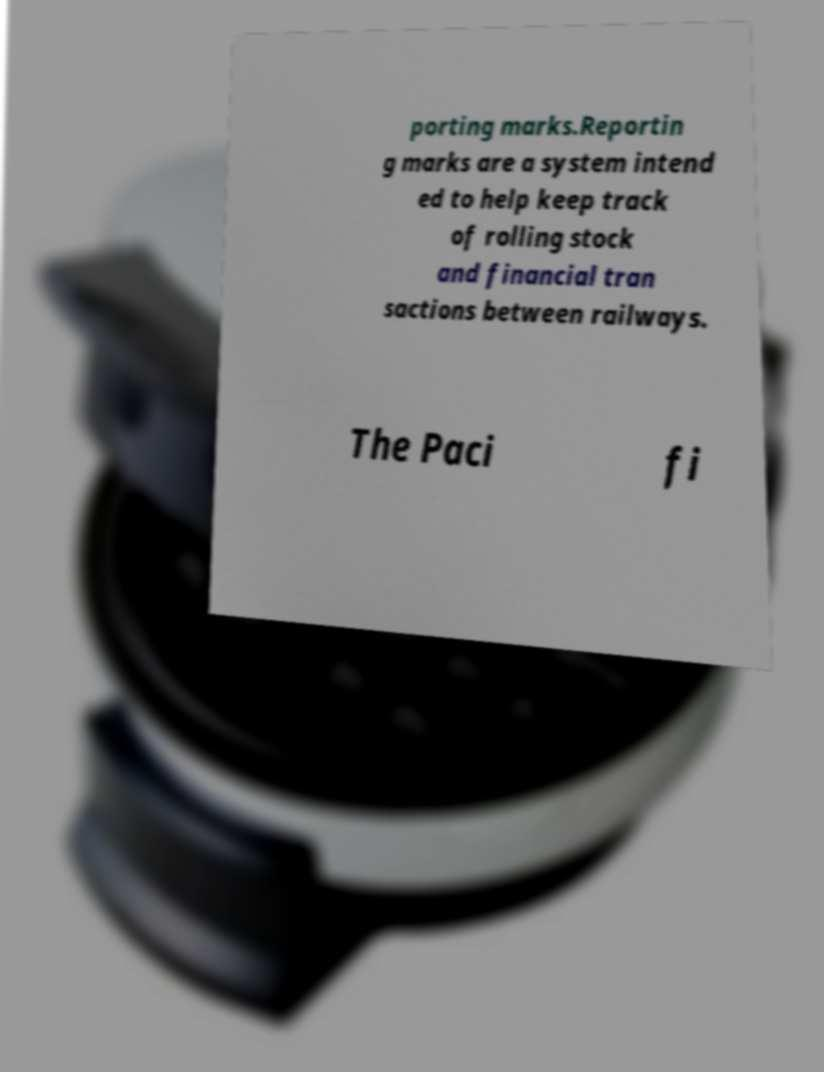Please read and relay the text visible in this image. What does it say? porting marks.Reportin g marks are a system intend ed to help keep track of rolling stock and financial tran sactions between railways. The Paci fi 